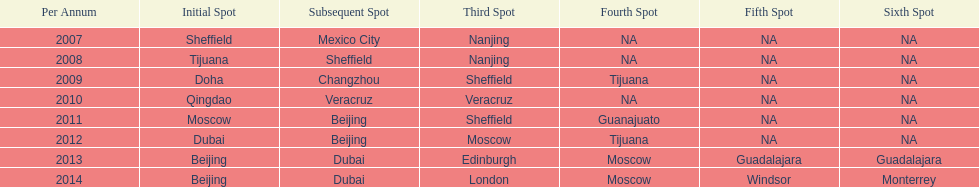Name a year whose second venue was the same as 2011. 2012. 